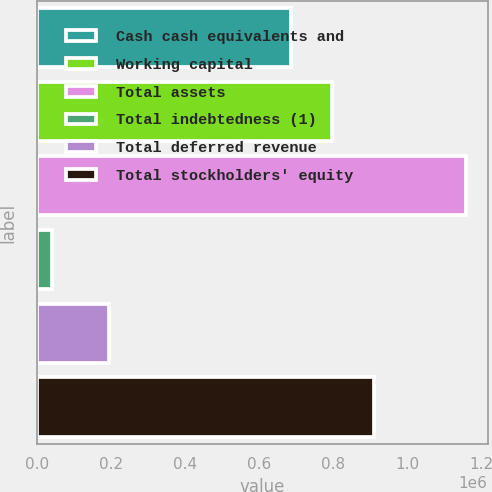Convert chart. <chart><loc_0><loc_0><loc_500><loc_500><bar_chart><fcel>Cash cash equivalents and<fcel>Working capital<fcel>Total assets<fcel>Total indebtedness (1)<fcel>Total deferred revenue<fcel>Total stockholders' equity<nl><fcel>687326<fcel>799060<fcel>1.15989e+06<fcel>42546<fcel>196808<fcel>910795<nl></chart> 